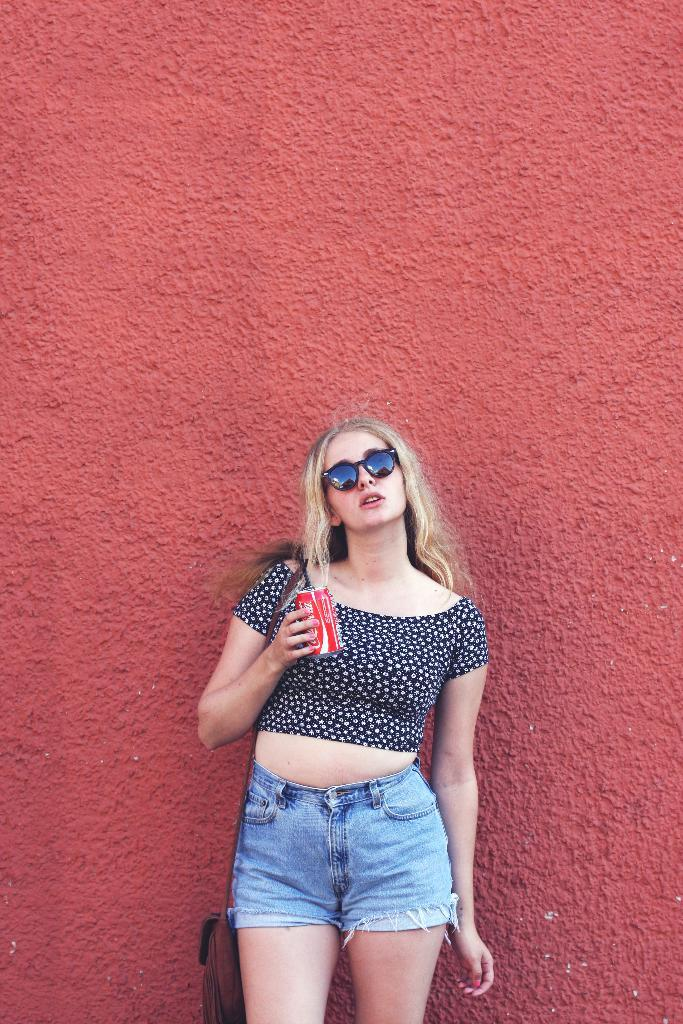What can be seen in the image? There is a person in the image. What is the person holding? The person is holding a red object. What color is the top that the person is wearing? The person is wearing a blue top. What type of bottoms is the person wearing? The person is wearing jeans shorts. What color is the background of the image? The background of the image is red. What type of knife is the person using to mark their territory in the image? There is no knife or territory mentioned in the image. The person is simply holding a red object, and the background is red. 